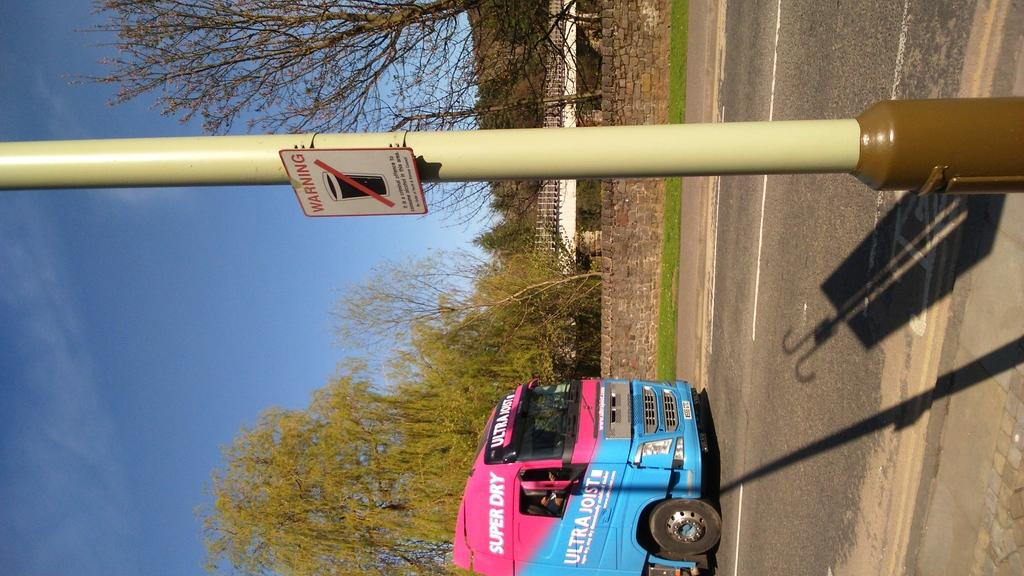Provide a one-sentence caption for the provided image. Pink and blue bus that says "Super Dry" next to a yellow pole. 